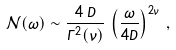<formula> <loc_0><loc_0><loc_500><loc_500>\mathcal { N } ( \omega ) \sim \frac { 4 \, D } { \Gamma ^ { 2 } ( \nu ) } \, \left ( \frac { \omega } { 4 D } \right ) ^ { 2 \nu } \, ,</formula> 